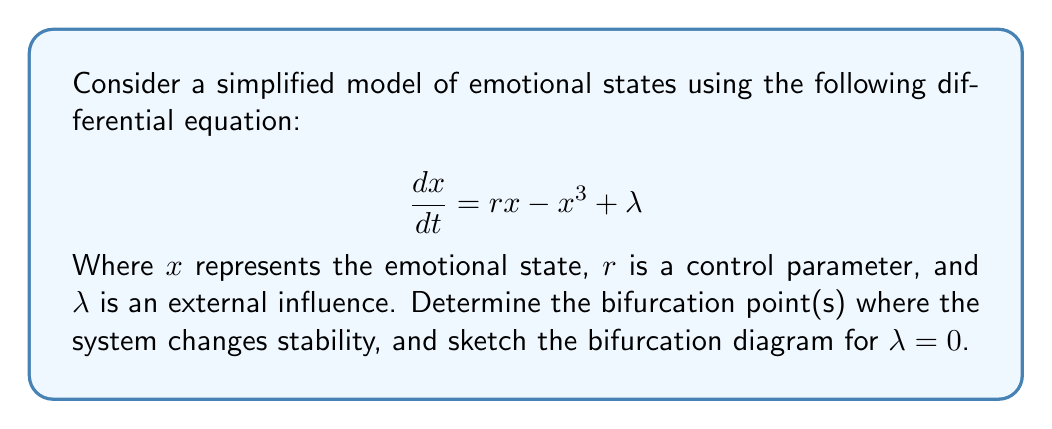What is the answer to this math problem? 1. To find the equilibrium points, set $\frac{dx}{dt} = 0$:
   $$rx - x^3 + \lambda = 0$$

2. For $\lambda = 0$, we have:
   $$rx - x^3 = 0$$
   $$x(r - x^2) = 0$$

3. Solving this equation, we get:
   $x = 0$ or $x = \pm\sqrt{r}$

4. The stability of these equilibrium points changes when $r$ changes sign. This occurs at $r = 0$, which is our bifurcation point.

5. To determine stability, we calculate the derivative of $\frac{dx}{dt}$ with respect to $x$:
   $$\frac{d}{dx}(\frac{dx}{dt}) = r - 3x^2$$

6. At $x = 0$, the stability is determined by the sign of $r$:
   - For $r < 0$, $x = 0$ is stable
   - For $r > 0$, $x = 0$ is unstable

7. For $x = \pm\sqrt{r}$ (when $r > 0$), we substitute:
   $$r - 3(\pm\sqrt{r})^2 = r - 3r = -2r < 0$$
   This indicates that $x = \pm\sqrt{r}$ are stable equilibrium points when they exist $(r > 0)$.

8. The bifurcation diagram for $\lambda = 0$ can be sketched as follows:

[asy]
import graph;
size(200,200);
real f(real x) {return sqrt(x);}
real g(real x) {return -sqrt(x);}
xaxis("r",arrow=Arrow);
yaxis("x",arrow=Arrow);
draw((-1,0)--(0,0),blue);
draw((0,0)--(2,0),dashed);
draw((0,0)--(2,f(2)),blue);
draw((0,0)--(2,g(2)),blue);
label("Stable",(-0.5,0),N);
label("Unstable",(1,0),S);
label("Stable",(1,0.5),NE);
label("Stable",(1,-0.5),SE);
dot((0,0));
[/asy]

This diagram illustrates a pitchfork bifurcation, where the system transitions from one stable equilibrium to two stable equilibria and one unstable equilibrium as $r$ increases past 0.
Answer: Bifurcation point: $r = 0$ 